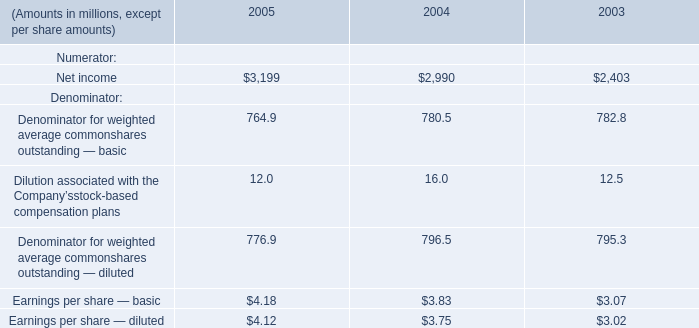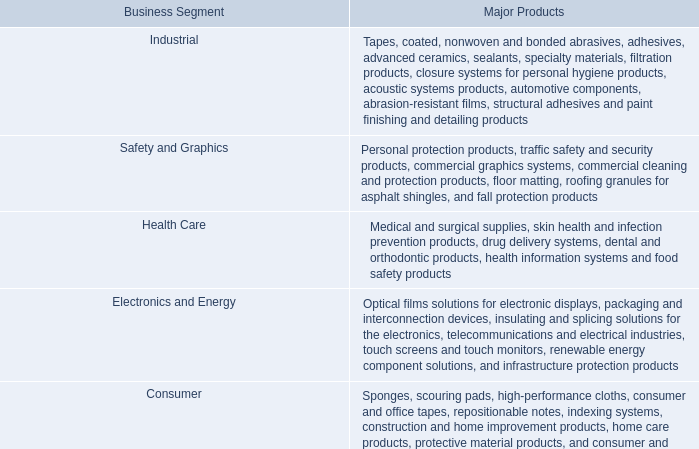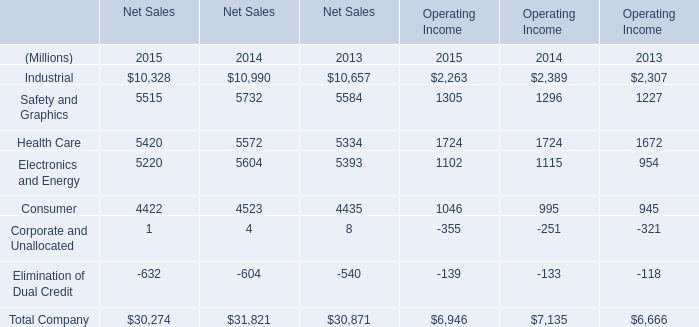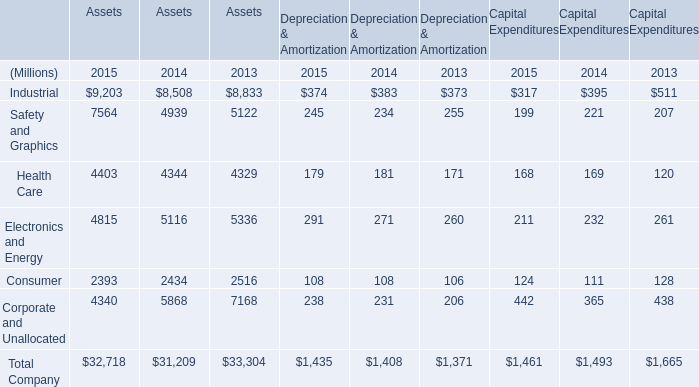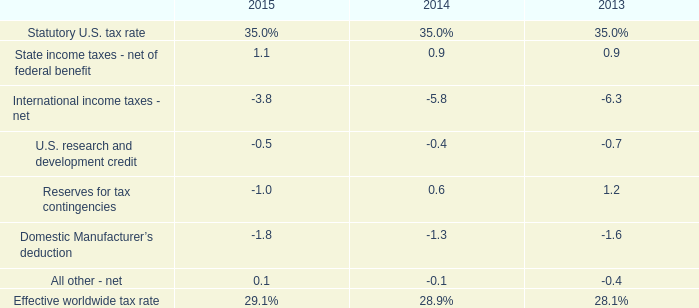What's the total amount of the elements in the years where Safety and Graphics for Assets greater than 7000? (in Million) 
Computations: (((((9203 + 7564) + 4403) + 4815) + 2393) + 4340)
Answer: 32718.0. 